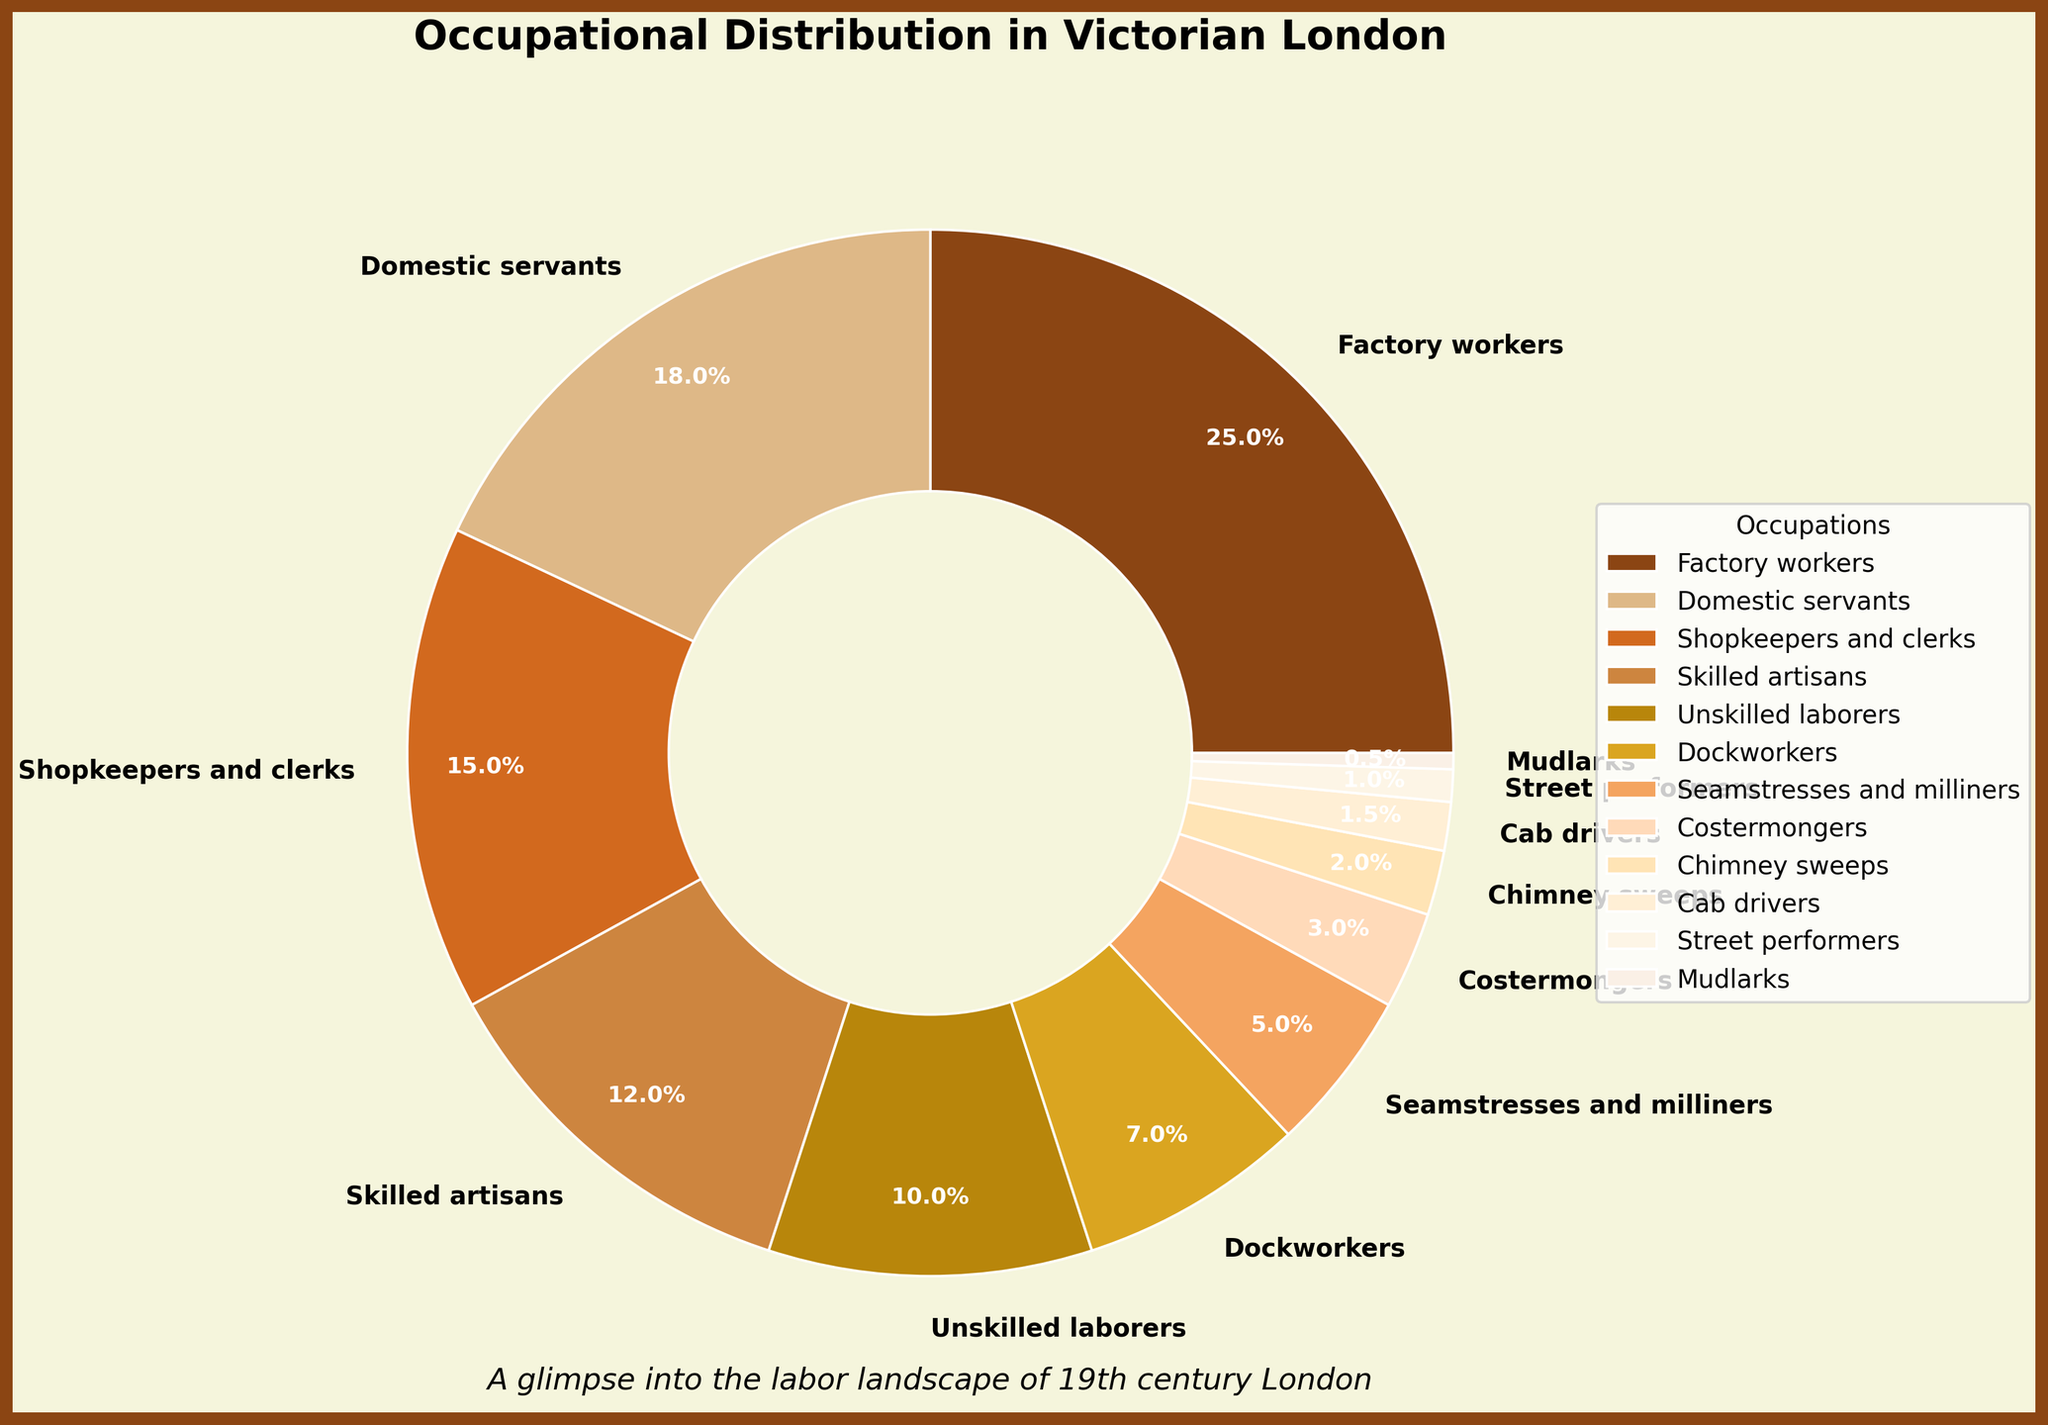What proportion of the occupational distribution is taken up by Factory Workers and Domestic Servants combined? To find the combined proportion of Factory Workers and Domestic Servants, add their percentages: Factory Workers (25%) + Domestic Servants (18%). This results in 25 + 18 = 43%.
Answer: 43% How does the percentage of Shopkeepers and Clerks compare to that of Chimney Sweeps? Shopkeepers and Clerks represent 15%, while Chimney Sweeps account for 2%. To compare, 15% is greater than 2%.
Answer: Shopkeepers and Clerks have a higher percentage Which occupation has the smallest percentage in the distribution? By observing the pie chart, the smallest percentage belongs to Mudlarks, who comprise 0.5% of the occupational distribution.
Answer: Mudlarks What is the sum of the percentages for Dockworkers, Seamstresses and Milliners, and Costermongers? Add the percentages of Dockworkers (7%), Seamstresses and Milliners (5%), and Costermongers (3%): 7 + 5 + 3 = 15%.
Answer: 15% If you combine Unskilled Laborers and Dockworkers, how does their total compare to Factory Workers? Unskilled Laborers are 10%, and Dockworkers are 7%, so their combined percentage is 10 + 7 = 17%. Factory Workers make up 25%. Therefore, 17% is less than 25%.
Answer: Combined percentage is less than Factory Workers Which three occupations are depicted using the lightest shades in the pie chart? Observe the colors that appear lightest in the visualization: Costermongers, Chimney Sweeps, and Street Performers.
Answer: Costermongers, Chimney Sweeps, Street Performers Between Skilled Artisans and Unskilled Laborers, which occupation is represented by a larger wedge in the pie chart? Skilled Artisans are at 12%, while Unskilled Laborers are at 10%. Hence, the pie chart's wedge for Skilled Artisans is larger.
Answer: Skilled Artisans Which occupation sectors collectively comprise just over half of the total distribution? Adding up the proportions: Factory Workers (25%), Domestic Servants (18%), and Shopkeepers and Clerks (15%) results in 25 + 18 + 15 = 58%. These three categories collectively make just over half.
Answer: Factory Workers, Domestic Servants, Shopkeepers and Clerks How does the percentage of Factory Workers compare to the total percentage of Skilled Artisans and Chimney Sweeps together? Skilled Artisans are 12% and Chimney Sweeps are 2%, so together they make up 12 + 2 = 14%. Factory Workers make up 25%, which is greater than the combined 14%.
Answer: Factory Workers have a higher percentage 